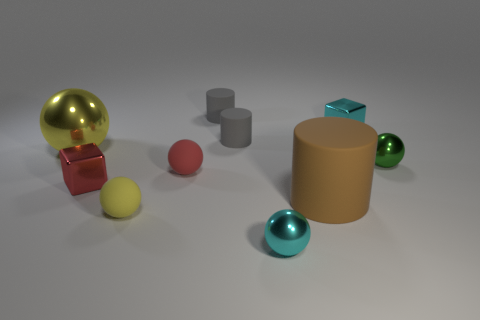Subtract all small rubber cylinders. How many cylinders are left? 1 Subtract 1 cubes. How many cubes are left? 1 Subtract all brown cylinders. How many cylinders are left? 2 Subtract all green spheres. How many gray cylinders are left? 2 Add 3 small gray things. How many small gray things are left? 5 Add 5 big brown cylinders. How many big brown cylinders exist? 6 Subtract 0 green cylinders. How many objects are left? 10 Subtract all cubes. How many objects are left? 8 Subtract all brown blocks. Subtract all cyan spheres. How many blocks are left? 2 Subtract all tiny blue metal cubes. Subtract all balls. How many objects are left? 5 